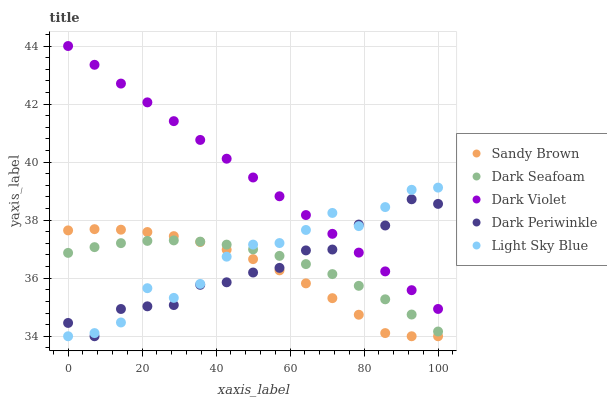Does Sandy Brown have the minimum area under the curve?
Answer yes or no. Yes. Does Dark Violet have the maximum area under the curve?
Answer yes or no. Yes. Does Light Sky Blue have the minimum area under the curve?
Answer yes or no. No. Does Light Sky Blue have the maximum area under the curve?
Answer yes or no. No. Is Dark Violet the smoothest?
Answer yes or no. Yes. Is Dark Periwinkle the roughest?
Answer yes or no. Yes. Is Light Sky Blue the smoothest?
Answer yes or no. No. Is Light Sky Blue the roughest?
Answer yes or no. No. Does Light Sky Blue have the lowest value?
Answer yes or no. Yes. Does Dark Violet have the lowest value?
Answer yes or no. No. Does Dark Violet have the highest value?
Answer yes or no. Yes. Does Light Sky Blue have the highest value?
Answer yes or no. No. Is Dark Seafoam less than Dark Violet?
Answer yes or no. Yes. Is Dark Violet greater than Sandy Brown?
Answer yes or no. Yes. Does Light Sky Blue intersect Dark Periwinkle?
Answer yes or no. Yes. Is Light Sky Blue less than Dark Periwinkle?
Answer yes or no. No. Is Light Sky Blue greater than Dark Periwinkle?
Answer yes or no. No. Does Dark Seafoam intersect Dark Violet?
Answer yes or no. No. 